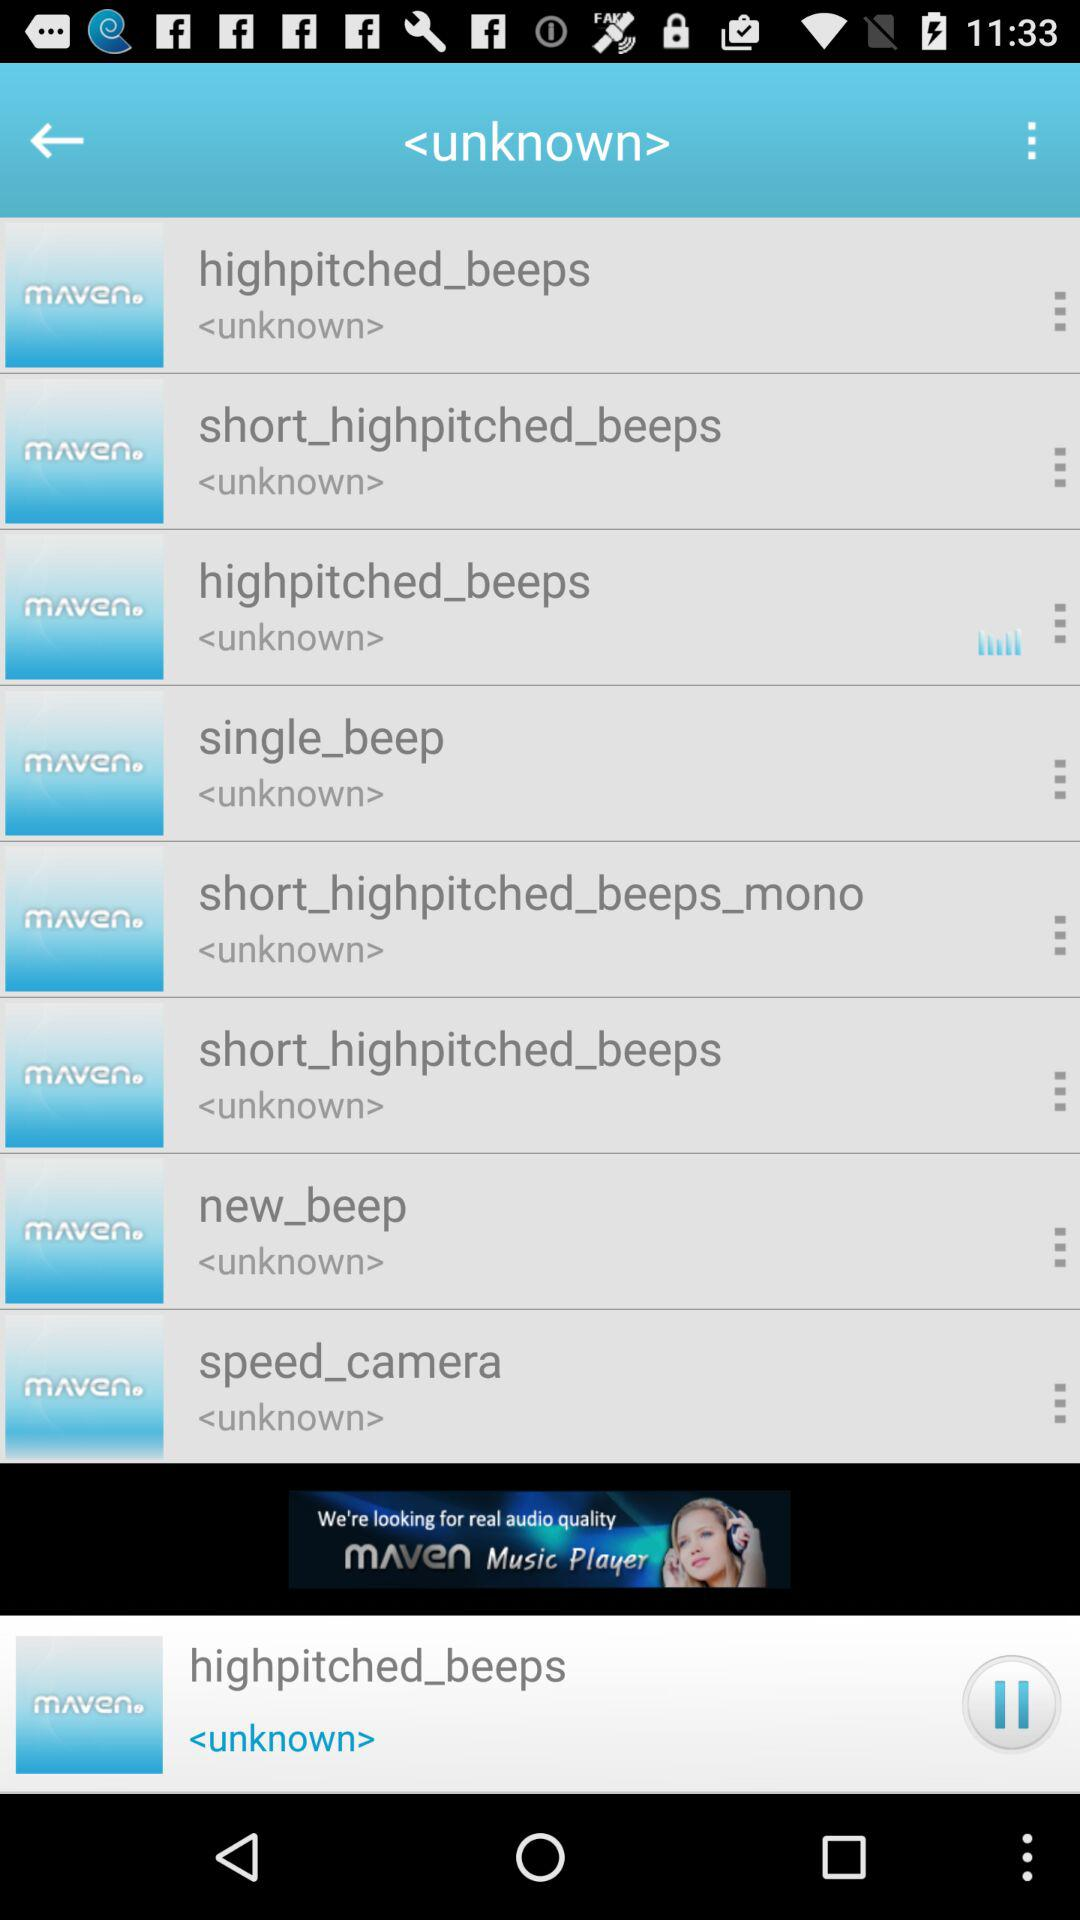What's the currently playing soundtrack? The currently playing soundtrack is "highpitched_beeps". 